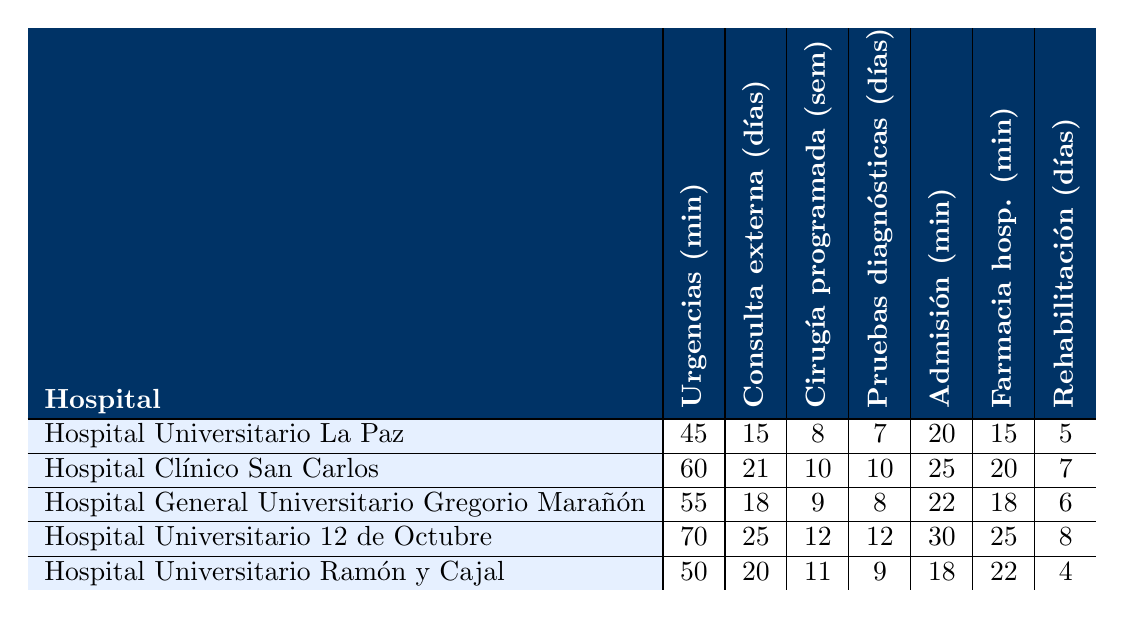¿Cuál es el tiempo promedio de espera en urgencias del Hospital Universitario Ramón y Cajal? El tiempo de espera en urgencias para el Hospital Universitario Ramón y Cajal está indicado directamente en la tabla como 50 minutos.
Answer: 50 minutos ¿Cuántos días de espera hay en promedio para consulta externa en el Hospital Clínico San Carlos? La tabla muestra que el tiempo de espera para consulta externa en el Hospital Clínico San Carlos es de 21 días.
Answer: 21 días ¿Qu&eacute; hospital tiene el mayor tiempo de espera para cirugía programada? Al revisar la columna de cirugía programada, el Hospital Universitario 12 de Octubre tiene el mayor tiempo de espera de 12 semanas.
Answer: Hospital Universitario 12 de Octubre ¿Cuál es la diferencia en días de espera entre las pruebas diagnósticas en el Hospital Universitario La Paz y el Hospital Universitario 12 de Octubre? El Hospital Universitario La Paz tiene un tiempo de espera de 7 días para pruebas diagnósticas, mientras que el Hospital Universitario 12 de Octubre tiene 12 días. La diferencia es 12 - 7 = 5 días.
Answer: 5 días ¿Qué hospital tiene los tiempos promedio de espera más bajos en farmacia hospitalaria? La tabla muestra que el Hospital Universitario La Paz tiene el tiempo más bajo de 15 minutos en farmacia hospitalaria.
Answer: Hospital Universitario La Paz ¿Es verdad que el Hospital General Universitario Gregorio Marañón tiene tiempos de espera más bajos que el Hospital Universitario 12 de Octubre en todos los servicios? Para responder, se revisan los tiempos de espera: en urgencias, el Hospital General Universitario Gregorio Marañón tiene 55 minutos, mientras que el Hospital Universitario 12 de Octubre tiene 70 minutos. En consulta externa, tiene 18 días frente a 25 días. En cirugía programada, tiene 9 semanas frente a 12 semanas. En pruebas diagnósticas, tiene 8 días frente a 12 días. En admisión, tiene 22 minutos frente a 30 minutos. En farmacia, tiene 18 minutos frente a 25 minutos. Como no es cierto en urgencias, la respuesta es no.
Answer: No ¿Cuál es el tiempo promedio de espera en días para rehabilitación en todos los hospitales combinados? Se suman los días de espera para rehabilitación de todos los hospitales: 5 + 7 + 6 + 8 + 4 = 30 días. Luego, se divide por el número de hospitales (5), lo que da un promedio de 30 / 5 = 6 días.
Answer: 6 días 